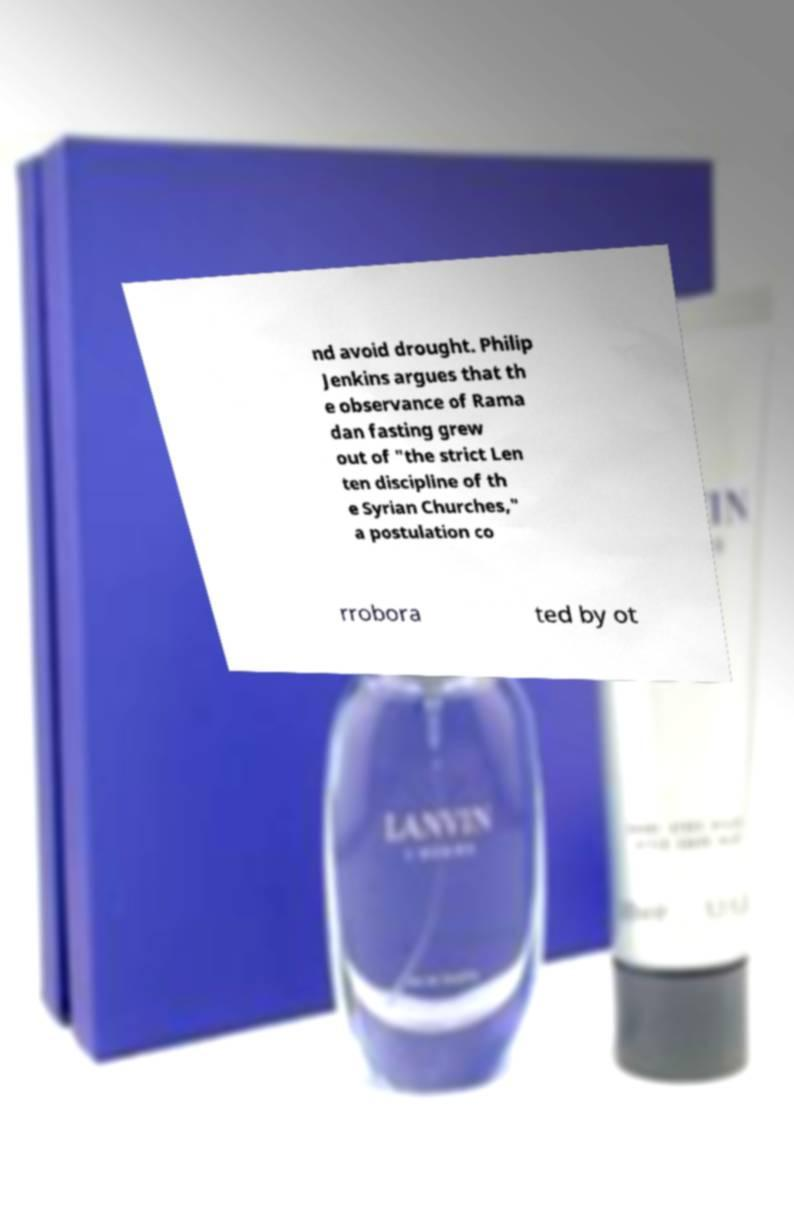For documentation purposes, I need the text within this image transcribed. Could you provide that? nd avoid drought. Philip Jenkins argues that th e observance of Rama dan fasting grew out of "the strict Len ten discipline of th e Syrian Churches," a postulation co rrobora ted by ot 